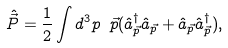Convert formula to latex. <formula><loc_0><loc_0><loc_500><loc_500>\hat { \vec { P } } = \frac { 1 } { 2 } \int d ^ { 3 } p \ { \vec { p } } ( \hat { a } ^ { \dag } _ { \vec { p } } \hat { a } _ { \vec { p } } + \hat { a } _ { \vec { p } } \hat { a } ^ { \dag } _ { \vec { p } } ) ,</formula> 